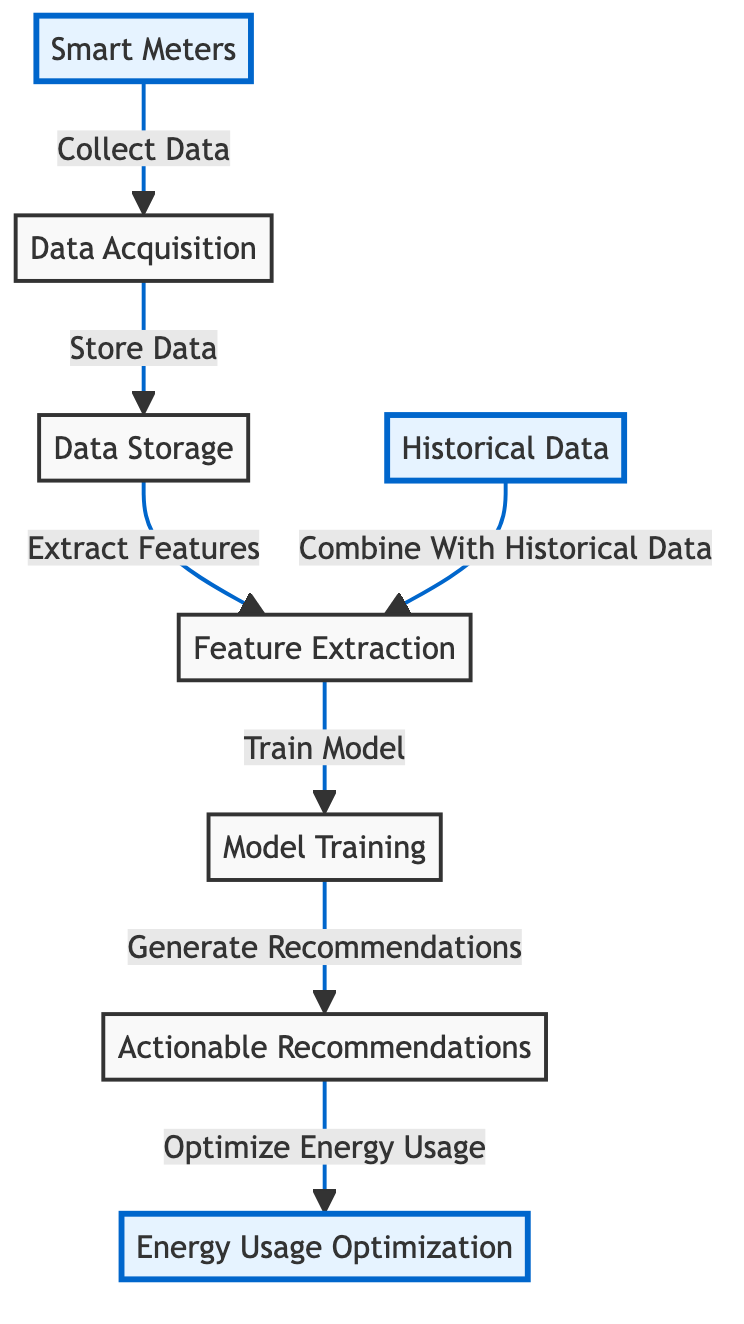What is the starting point of data collection in the diagram? The starting point of data collection in the diagram is labeled as "Smart Meters," indicating where the data is initially gathered before further processing steps.
Answer: Smart Meters How many main nodes are present in the diagram? By counting all distinct nodes in the diagram, which include Smart Meters, Data Acquisition, Data Storage, Feature Extraction, Historical Data, Model Training, Recommendations, and Energy Usage Optimization, we find there are a total of 8 main nodes.
Answer: 8 What type of data is combined with historical data during feature extraction? The diagram indicates that the "Feature Extraction" node combines "Historical Data" with the data acquired from current smart meters to enhance the feature extraction process.
Answer: Data from smart meters Which node directly generates actionable recommendations? The "Model Training" node is responsible for generating "Actionable Recommendations," indicating that model training results in suggestions to optimize energy usage.
Answer: Model Training What connects the "Data Acquisition" node to "Data Storage"? The connection between the "Data Acquisition" node and "Data Storage" node is described with the phrase "Store Data," indicating that the data collected is then stored for further use in subsequent steps.
Answer: Store Data Which step is performed after feature extraction? After the feature extraction process is completed, the next step indicated in the flow of the diagram is "Train Model," which shows that extracted features are used to train a machine learning model.
Answer: Train Model What is the final outcome of following the sequence in the diagram? The flow of the diagram culminates in the node labeled "Energy Usage Optimization," indicating that the final outcome is to optimize energy usage in manufacturing plants based on the prior processes.
Answer: Energy Usage Optimization How is historical data utilized in the diagram? The diagram shows that historical data is combined with current data during the "Feature Extraction" stage, enhancing the relevance and accuracy of features extracted for model training.
Answer: Combine With Historical Data 